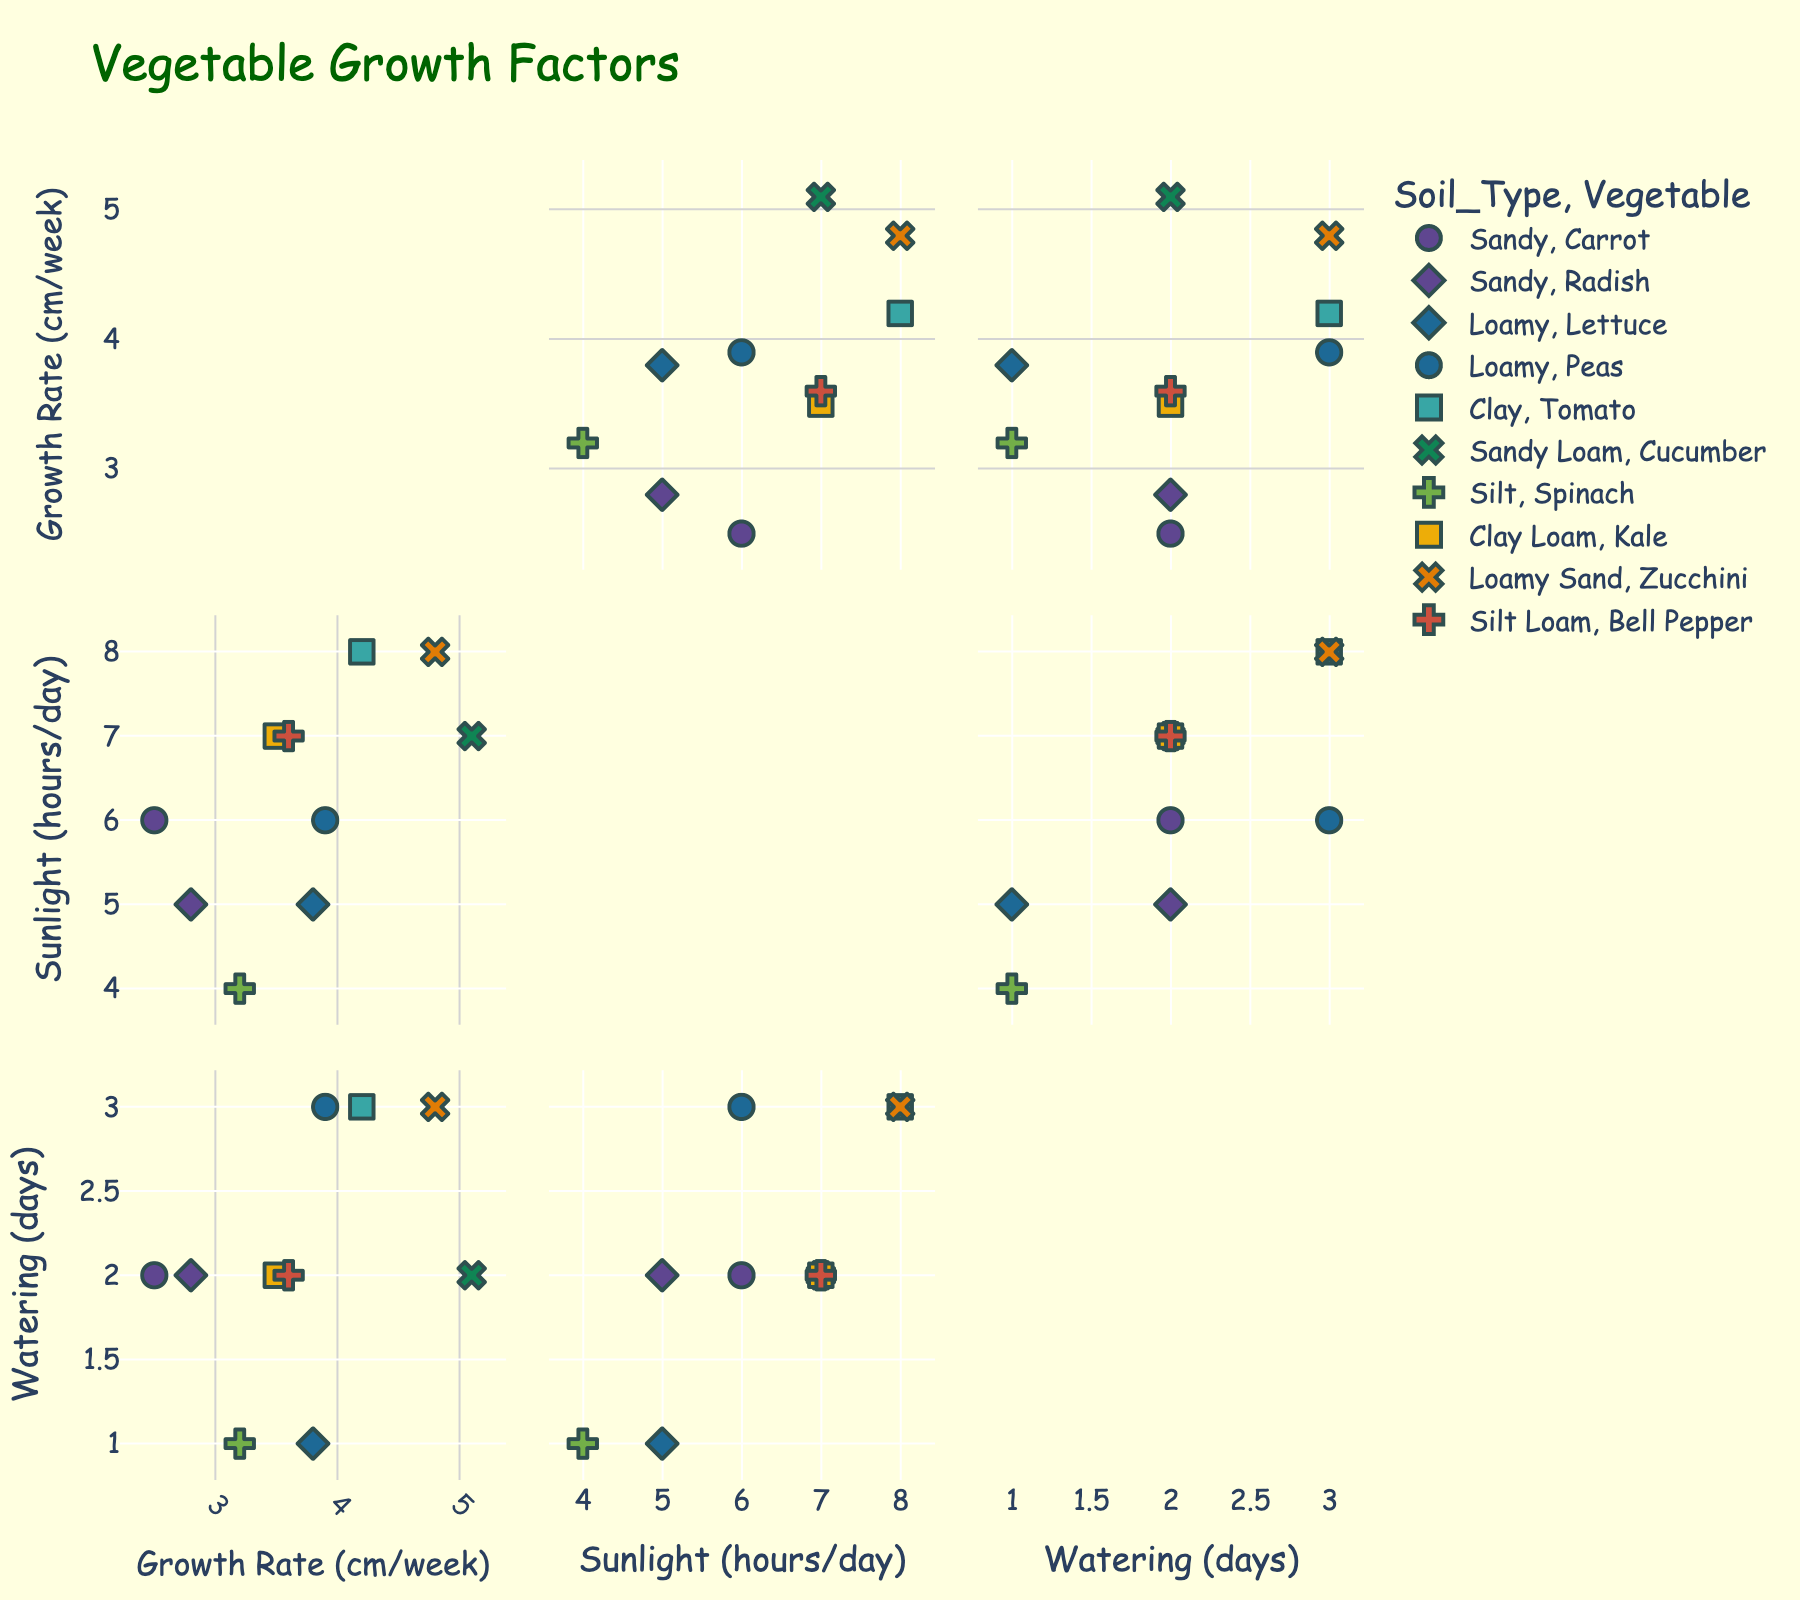what is the title of the plot? The title of the plot is usually displayed at the top of the figure. In this case, the plot has the title "Vegetable Growth Factors".
Answer: Vegetable Growth Factors how many vegetables are represented in the plot? By looking at the legend or the data points labeled with different symbols, we see there are ten different vegetables represented in the plot.
Answer: 10 which vegetable requires the highest amount of sunlight per day? By checking the data points corresponding to the "Sunlight_Hours_per_Day" dimension, the vegetable with the highest sunlight requirement (8 hours/day) is Tomato and Zucchini.
Answer: Tomato, Zucchini what is the soil type with the highest average growth rate? To find this, we need to calculate the average growth rate for each soil type using the data points marked with different colors, and compare them to find the highest.
Answer: Loamy Sand is there a vegetable that has a high growth rate but low sunlight hours per day? We need to look for a vegetable data point with high values on the "Growth_Rate_cm_per_week" axis and simultaneously low values on the "Sunlight_Hours_per_Day" axis. Spinach (3.2 cm/week, 4 hours/day) fits this description.
Answer: Spinach which vegetables need watering every 2 days? Check the data points corresponding to the "Watering_Frequency_Days" dimension for values equal to 2. Vegetables with this watering frequency are Carrot, Cucumber, Radish, Kale, and Bell Pepper.
Answer: Carrot, Cucumber, Radish, Kale, Bell Pepper which soil type appears the most frequently in the figure? To answer this, count the number of data points for each soil type and identify the one that appears most frequently.
Answer: Loamy among Lettuce, Tomato, and Cucumber, which one has the highest growth rate? Compare the growth rate values of Lettuce (3.8 cm/week), Tomato (4.2 cm/week), and Cucumber (5.1 cm/week) to find the one with the highest value.
Answer: Cucumber 